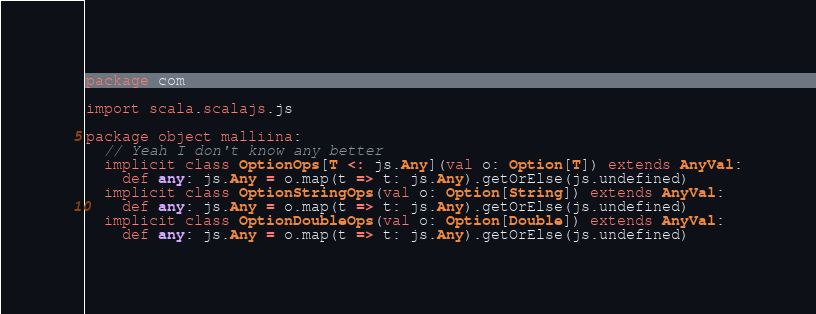<code> <loc_0><loc_0><loc_500><loc_500><_Scala_>package com

import scala.scalajs.js

package object malliina:
  // Yeah I don't know any better
  implicit class OptionOps[T <: js.Any](val o: Option[T]) extends AnyVal:
    def any: js.Any = o.map(t => t: js.Any).getOrElse(js.undefined)
  implicit class OptionStringOps(val o: Option[String]) extends AnyVal:
    def any: js.Any = o.map(t => t: js.Any).getOrElse(js.undefined)
  implicit class OptionDoubleOps(val o: Option[Double]) extends AnyVal:
    def any: js.Any = o.map(t => t: js.Any).getOrElse(js.undefined)
</code> 